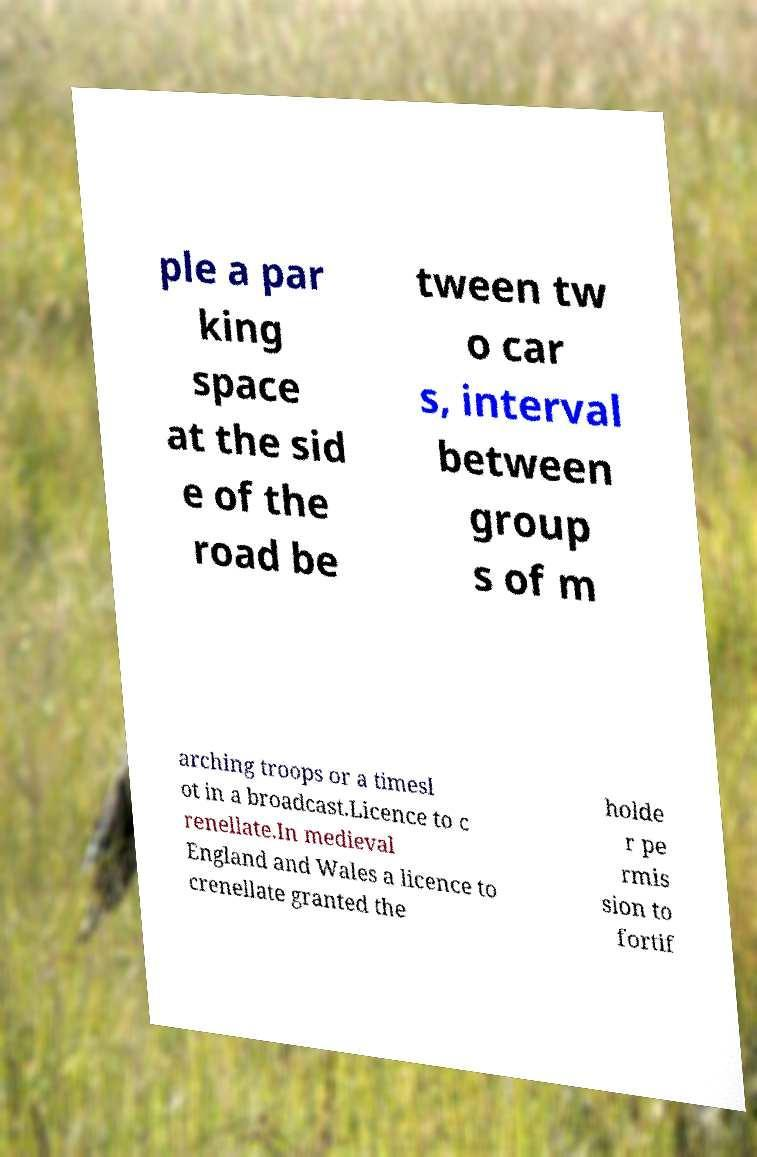Please identify and transcribe the text found in this image. ple a par king space at the sid e of the road be tween tw o car s, interval between group s of m arching troops or a timesl ot in a broadcast.Licence to c renellate.In medieval England and Wales a licence to crenellate granted the holde r pe rmis sion to fortif 